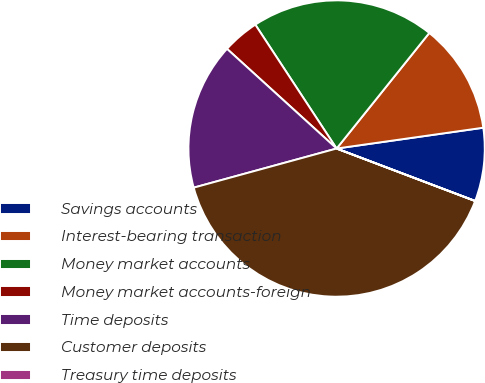Convert chart. <chart><loc_0><loc_0><loc_500><loc_500><pie_chart><fcel>Savings accounts<fcel>Interest-bearing transaction<fcel>Money market accounts<fcel>Money market accounts-foreign<fcel>Time deposits<fcel>Customer deposits<fcel>Treasury time deposits<nl><fcel>8.0%<fcel>12.0%<fcel>20.0%<fcel>4.01%<fcel>16.0%<fcel>39.98%<fcel>0.01%<nl></chart> 